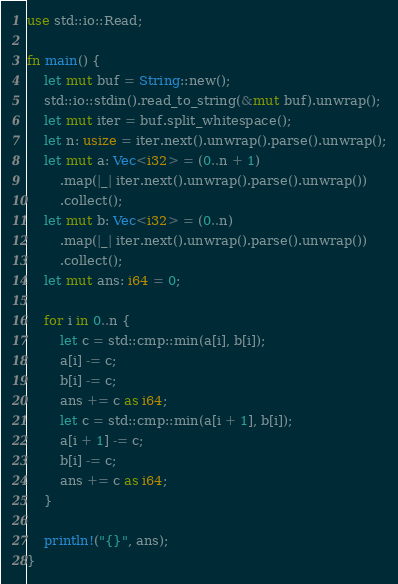<code> <loc_0><loc_0><loc_500><loc_500><_Rust_>use std::io::Read;

fn main() {
    let mut buf = String::new();
    std::io::stdin().read_to_string(&mut buf).unwrap();
    let mut iter = buf.split_whitespace();
    let n: usize = iter.next().unwrap().parse().unwrap();
    let mut a: Vec<i32> = (0..n + 1)
        .map(|_| iter.next().unwrap().parse().unwrap())
        .collect();
    let mut b: Vec<i32> = (0..n)
        .map(|_| iter.next().unwrap().parse().unwrap())
        .collect();
    let mut ans: i64 = 0;

    for i in 0..n {
        let c = std::cmp::min(a[i], b[i]);
        a[i] -= c;
        b[i] -= c;
        ans += c as i64;
        let c = std::cmp::min(a[i + 1], b[i]);
        a[i + 1] -= c;
        b[i] -= c;
        ans += c as i64;
    }

    println!("{}", ans);
}
</code> 